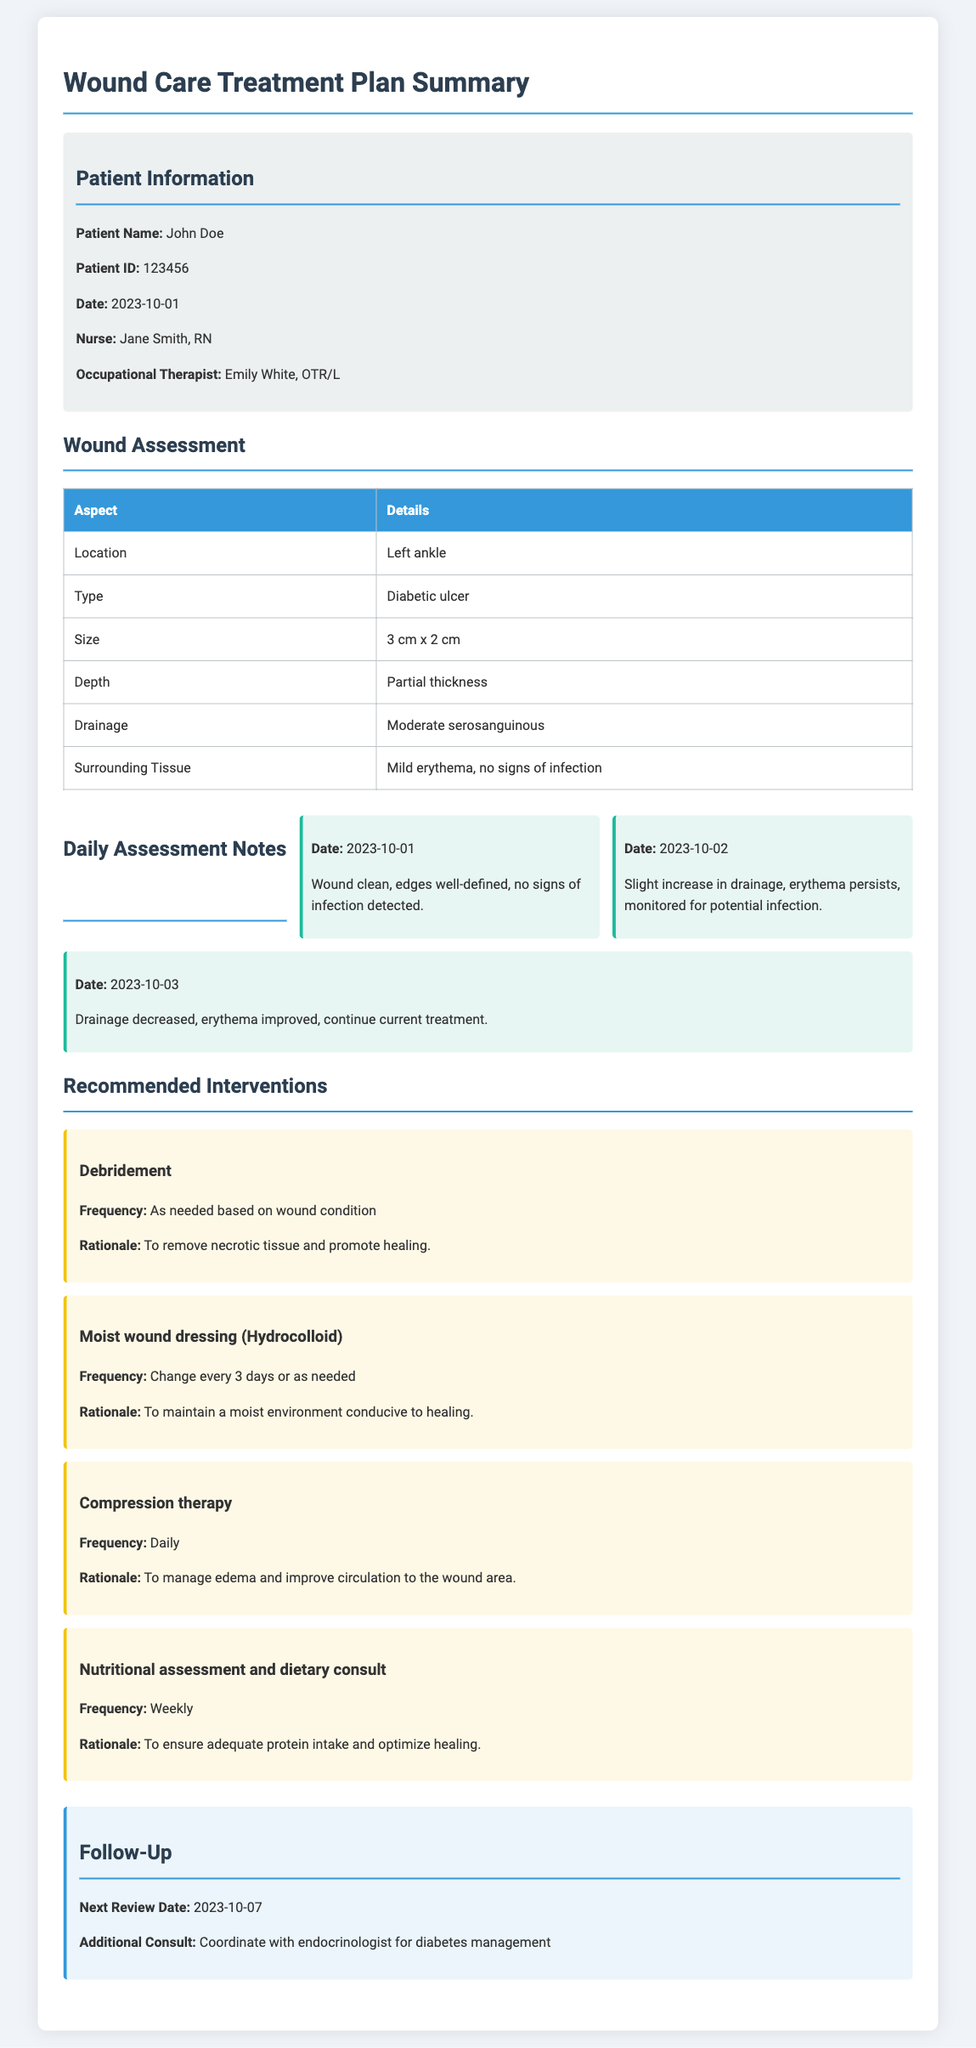What is the patient's name? The patient's name is mentioned in the patient information section.
Answer: John Doe What type of wound is being treated? The type of wound is specified in the wound assessment section.
Answer: Diabetic ulcer What is the size of the wound? The size of the wound is provided in the wound assessment section.
Answer: 3 cm x 2 cm What date is the next review scheduled? The next review date is found in the follow-up section.
Answer: 2023-10-07 What is the frequency of compression therapy? The frequency for compression therapy is stated in the recommended interventions section.
Answer: Daily What is the rationale for using moist wound dressing? The rationale for moist wound dressing is explained in the interventions section.
Answer: To maintain a moist environment conducive to healing How many daily assessment notes are documented? The number of daily assessment notes can be counted in the daily assessment notes section.
Answer: 3 What is recommended for nutritional assessment? The recommendation for nutritional assessment is provided in the interventions.
Answer: Dietary consult What is the surrounding tissue condition? The condition of the surrounding tissue is detailed in the wound assessment section.
Answer: Mild erythema, no signs of infection 